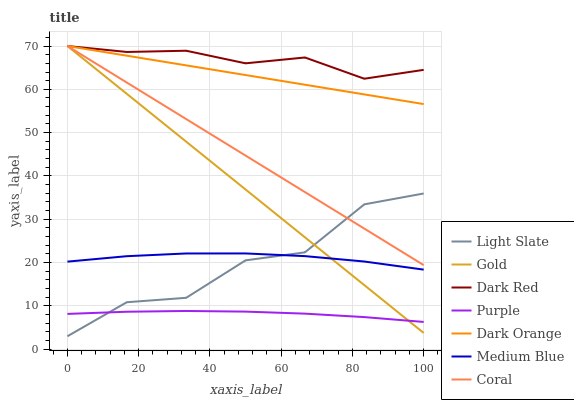Does Purple have the minimum area under the curve?
Answer yes or no. Yes. Does Dark Red have the maximum area under the curve?
Answer yes or no. Yes. Does Gold have the minimum area under the curve?
Answer yes or no. No. Does Gold have the maximum area under the curve?
Answer yes or no. No. Is Coral the smoothest?
Answer yes or no. Yes. Is Light Slate the roughest?
Answer yes or no. Yes. Is Gold the smoothest?
Answer yes or no. No. Is Gold the roughest?
Answer yes or no. No. Does Light Slate have the lowest value?
Answer yes or no. Yes. Does Gold have the lowest value?
Answer yes or no. No. Does Coral have the highest value?
Answer yes or no. Yes. Does Light Slate have the highest value?
Answer yes or no. No. Is Purple less than Coral?
Answer yes or no. Yes. Is Coral greater than Purple?
Answer yes or no. Yes. Does Medium Blue intersect Light Slate?
Answer yes or no. Yes. Is Medium Blue less than Light Slate?
Answer yes or no. No. Is Medium Blue greater than Light Slate?
Answer yes or no. No. Does Purple intersect Coral?
Answer yes or no. No. 